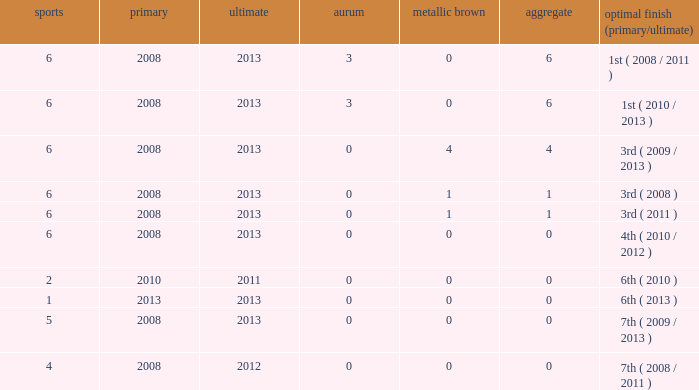What is the latest first year with 0 total medals and over 0 golds? 2008.0. 